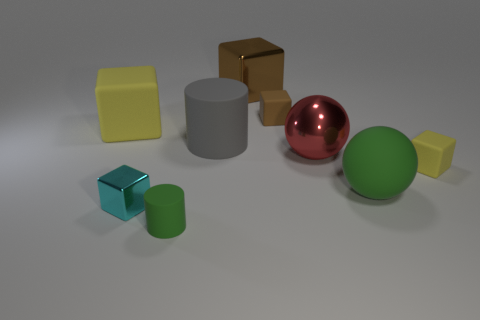The green cylinder is what size? The green cylinder appears to be medium-sized when compared to the other objects in the scene, such as the smaller green cube and the larger yellow cube. 